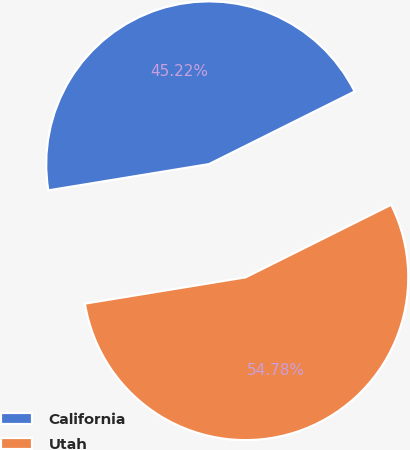<chart> <loc_0><loc_0><loc_500><loc_500><pie_chart><fcel>California<fcel>Utah<nl><fcel>45.22%<fcel>54.78%<nl></chart> 